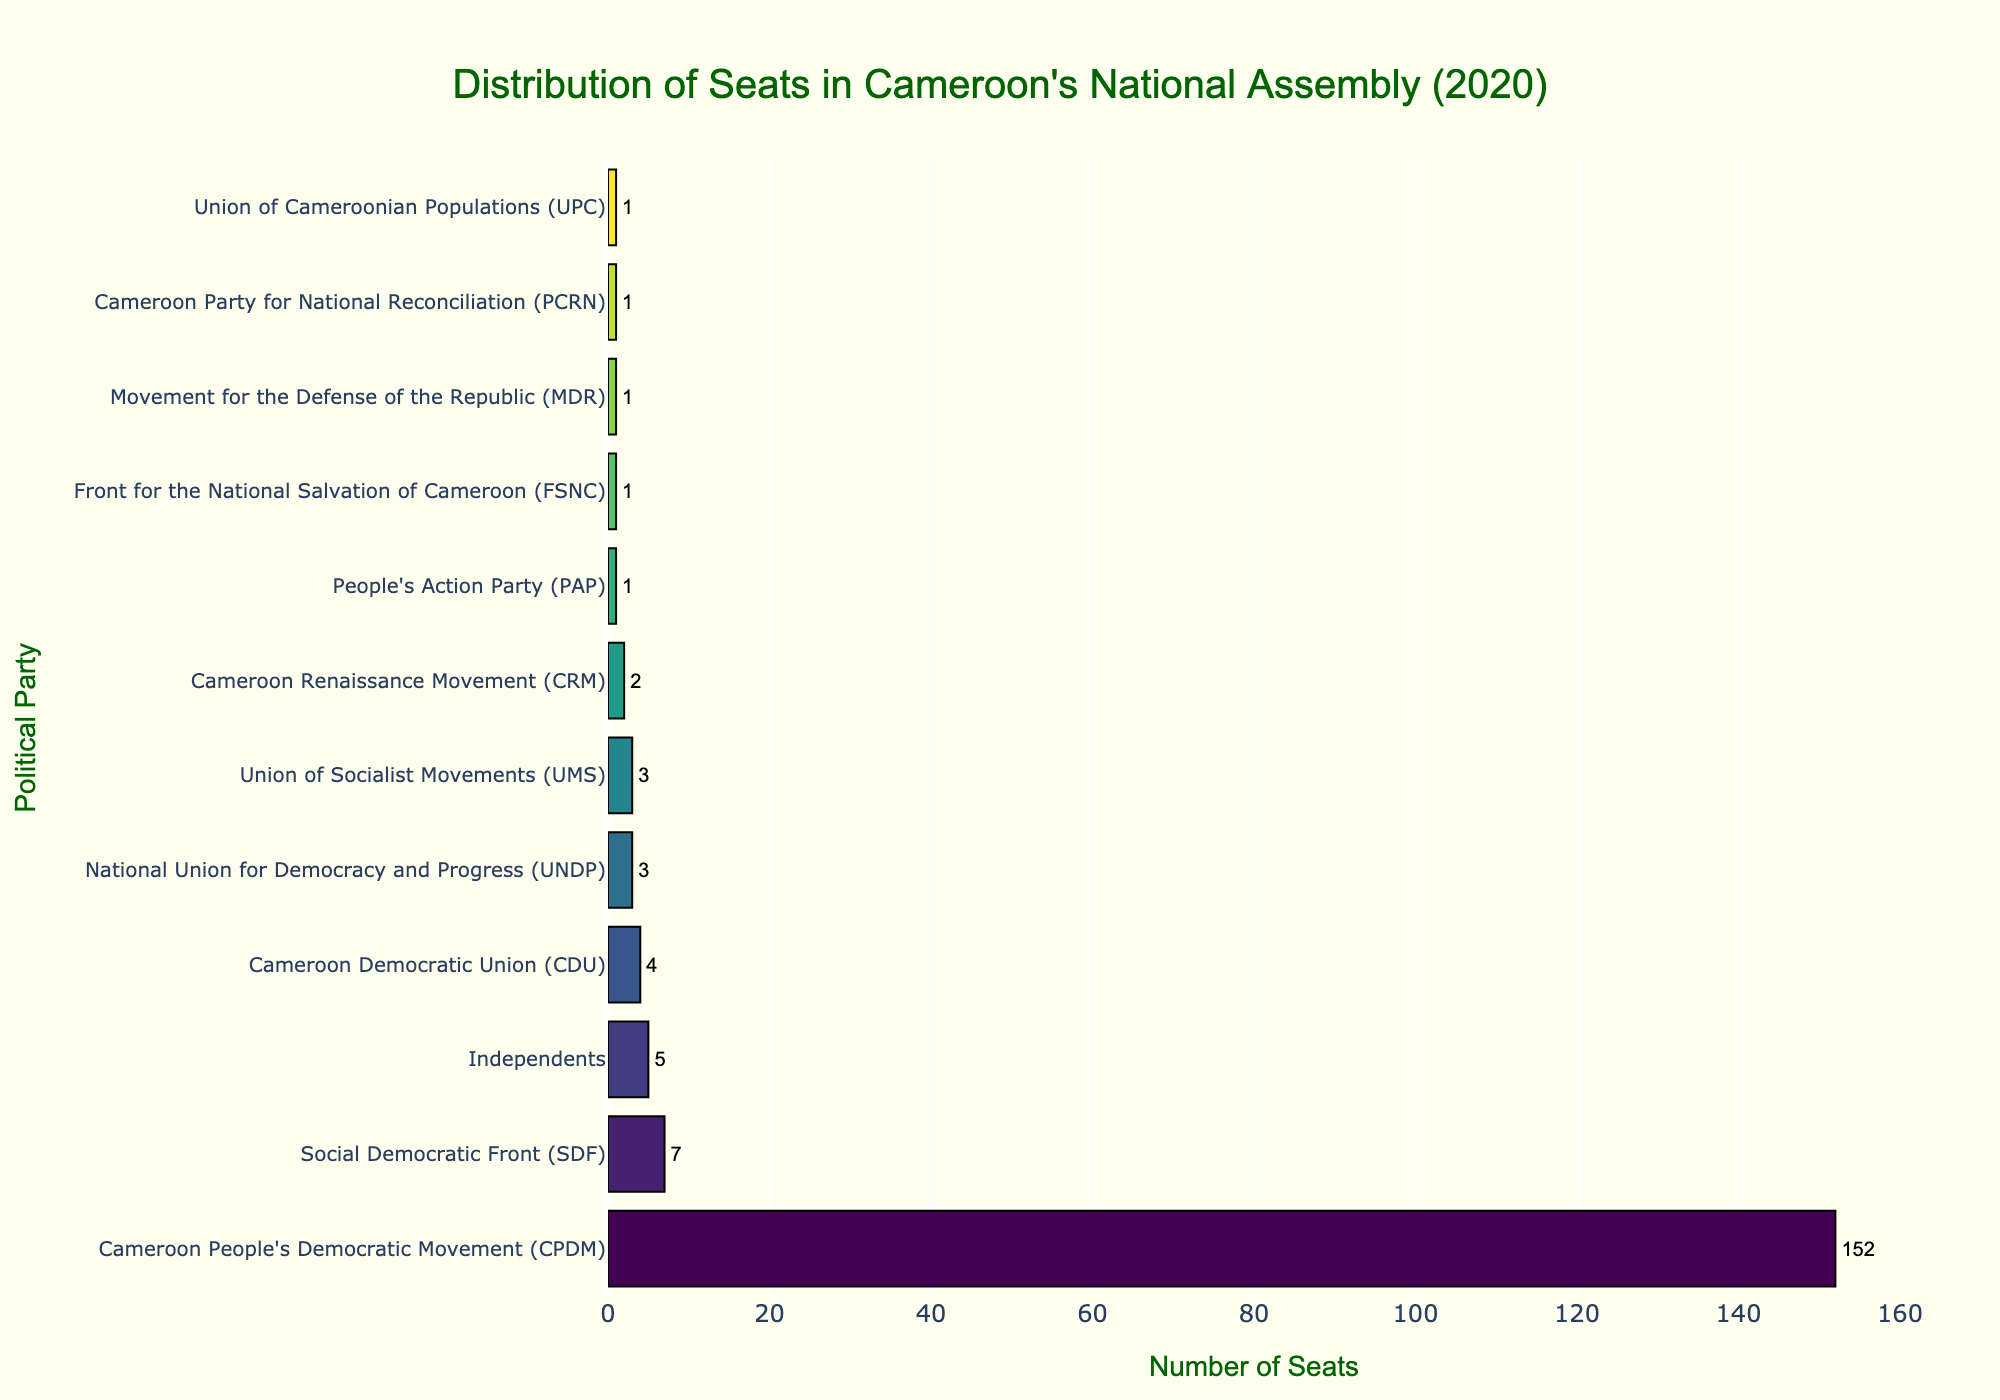What is the total number of seats held by all political parties combined? To find the total number of seats, sum the seats of all the political parties. The seats are 152 (CPDM) + 7 (SDF) + 4 (CDU) + 3 (UNDP) + 3 (UMS) + 2 (CRM) + 1 (PAP) + 1 (FSNC) + 1 (MDR) + 1 (PCRN) + 1 (UPC) + 5 (Independents). The total is 181.
Answer: 181 Which political party holds the highest number of seats and how many? Look at the horizontal bar that extends furthest to the right, representing the highest value, which is CPDM with 152 seats.
Answer: Cameroon People's Democratic Movement (CPDM), 152 How many more seats does CPDM have compared to SDF? Subtract the number of seats held by SDF from the seats held by CPDM: 152 (CPDM) - 7 (SDF) = 145.
Answer: 145 Which political parties hold exactly one seat each? Identify the bars that represent a quantity of 1 seat. These parties are PAP, FSNC, MDR, PCRN, and UPC.
Answer: PAP, FSNC, MDR, PCRN, UPC What is the percentage of seats held by Independents out of the total seats? First, find the total number of seats (181). Then, calculate the percentage of seats held by Independents: (5/181) * 100. This equals approximately 2.76%.
Answer: 2.76% Are there any political parties with the same number of seats? If so, which ones? Identify bars of equal length. Both UNDP and UMS have 3 seats each.
Answer: UNDP, UMS How many parties hold fewer than 5 seats? Count the number of bars representing fewer than 5 seats. The parties are SDF, CDU, UNDP, UMS, CRM, PAP, FSNC, MDR, PCRN, and UPC, which totals 10 parties.
Answer: 10 Which party is the second largest in terms of seats held, and how many seats do they have? Identify the second-longest bar. This is SDF with 7 seats.
Answer: Social Democratic Front (SDF), 7 What is the average number of seats held by the parties (excluding Independents)? First, sum the number of seats held by all parties excluding Independents. This is 176. Then, divide by the number of these parties (11). The average is 176/11 = 16.
Answer: 16 Which party holds the least number of seats, and how many seats is that? Identify the shortest bars. Each of PAP, FSNC, MDR, PCRN, and UPC hold 1 seat.
Answer: PAP, FSNC, MDR, PCRN, UPC, 1 